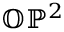<formula> <loc_0><loc_0><loc_500><loc_500>\mathbb { O P } ^ { 2 }</formula> 